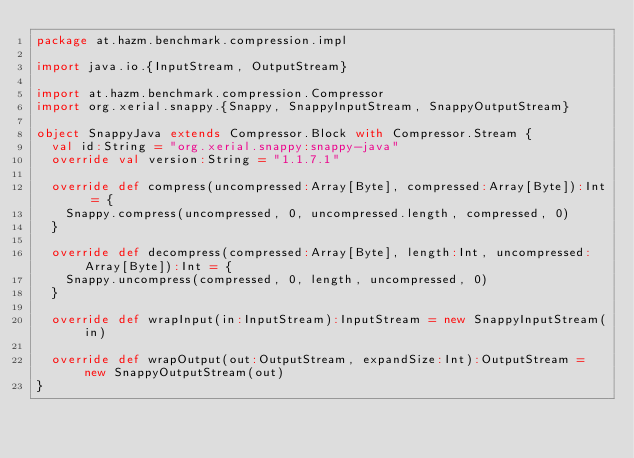Convert code to text. <code><loc_0><loc_0><loc_500><loc_500><_Scala_>package at.hazm.benchmark.compression.impl

import java.io.{InputStream, OutputStream}

import at.hazm.benchmark.compression.Compressor
import org.xerial.snappy.{Snappy, SnappyInputStream, SnappyOutputStream}

object SnappyJava extends Compressor.Block with Compressor.Stream {
  val id:String = "org.xerial.snappy:snappy-java"
  override val version:String = "1.1.7.1"

  override def compress(uncompressed:Array[Byte], compressed:Array[Byte]):Int = {
    Snappy.compress(uncompressed, 0, uncompressed.length, compressed, 0)
  }

  override def decompress(compressed:Array[Byte], length:Int, uncompressed:Array[Byte]):Int = {
    Snappy.uncompress(compressed, 0, length, uncompressed, 0)
  }

  override def wrapInput(in:InputStream):InputStream = new SnappyInputStream(in)

  override def wrapOutput(out:OutputStream, expandSize:Int):OutputStream = new SnappyOutputStream(out)
}
</code> 